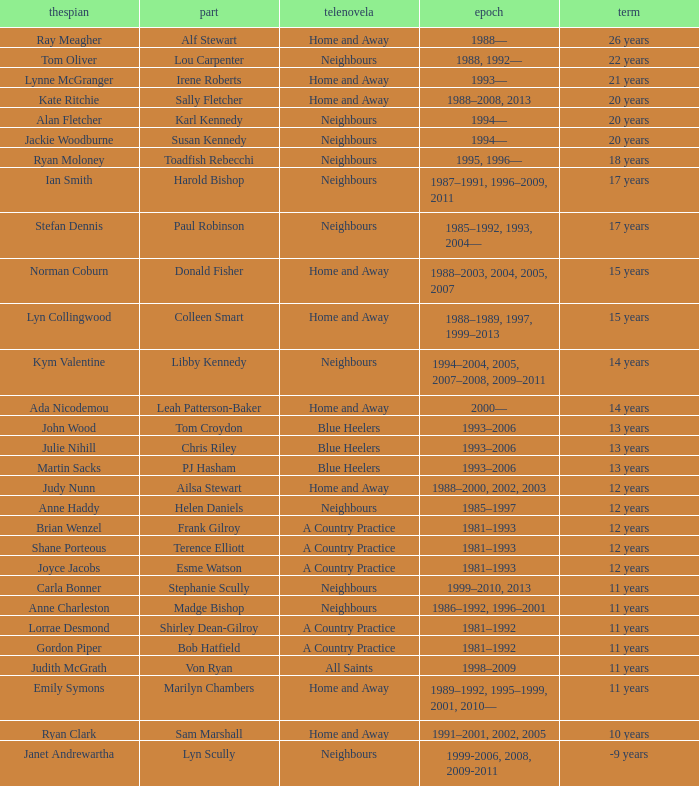What role was played by the same artist for 12 years on neighbours? Helen Daniels. 